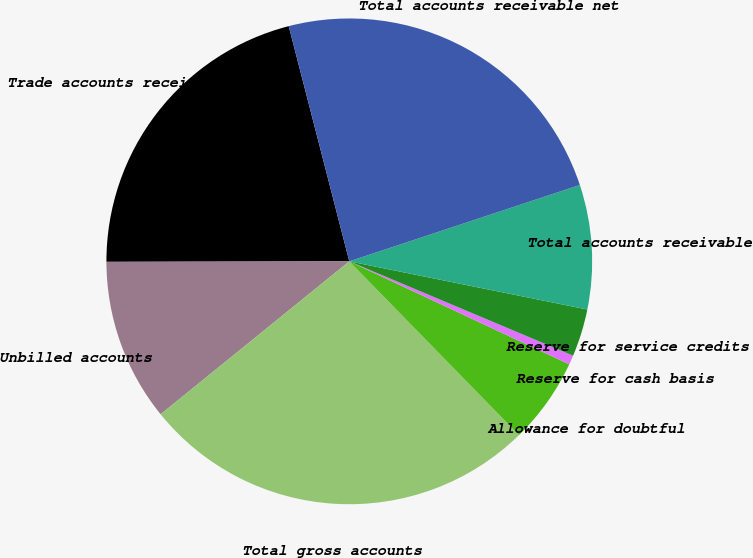Convert chart to OTSL. <chart><loc_0><loc_0><loc_500><loc_500><pie_chart><fcel>Trade accounts receivable<fcel>Unbilled accounts<fcel>Total gross accounts<fcel>Allowance for doubtful<fcel>Reserve for cash basis<fcel>Reserve for service credits<fcel>Total accounts receivable<fcel>Total accounts receivable net<nl><fcel>21.02%<fcel>10.81%<fcel>26.47%<fcel>5.72%<fcel>0.62%<fcel>3.17%<fcel>8.27%<fcel>23.92%<nl></chart> 